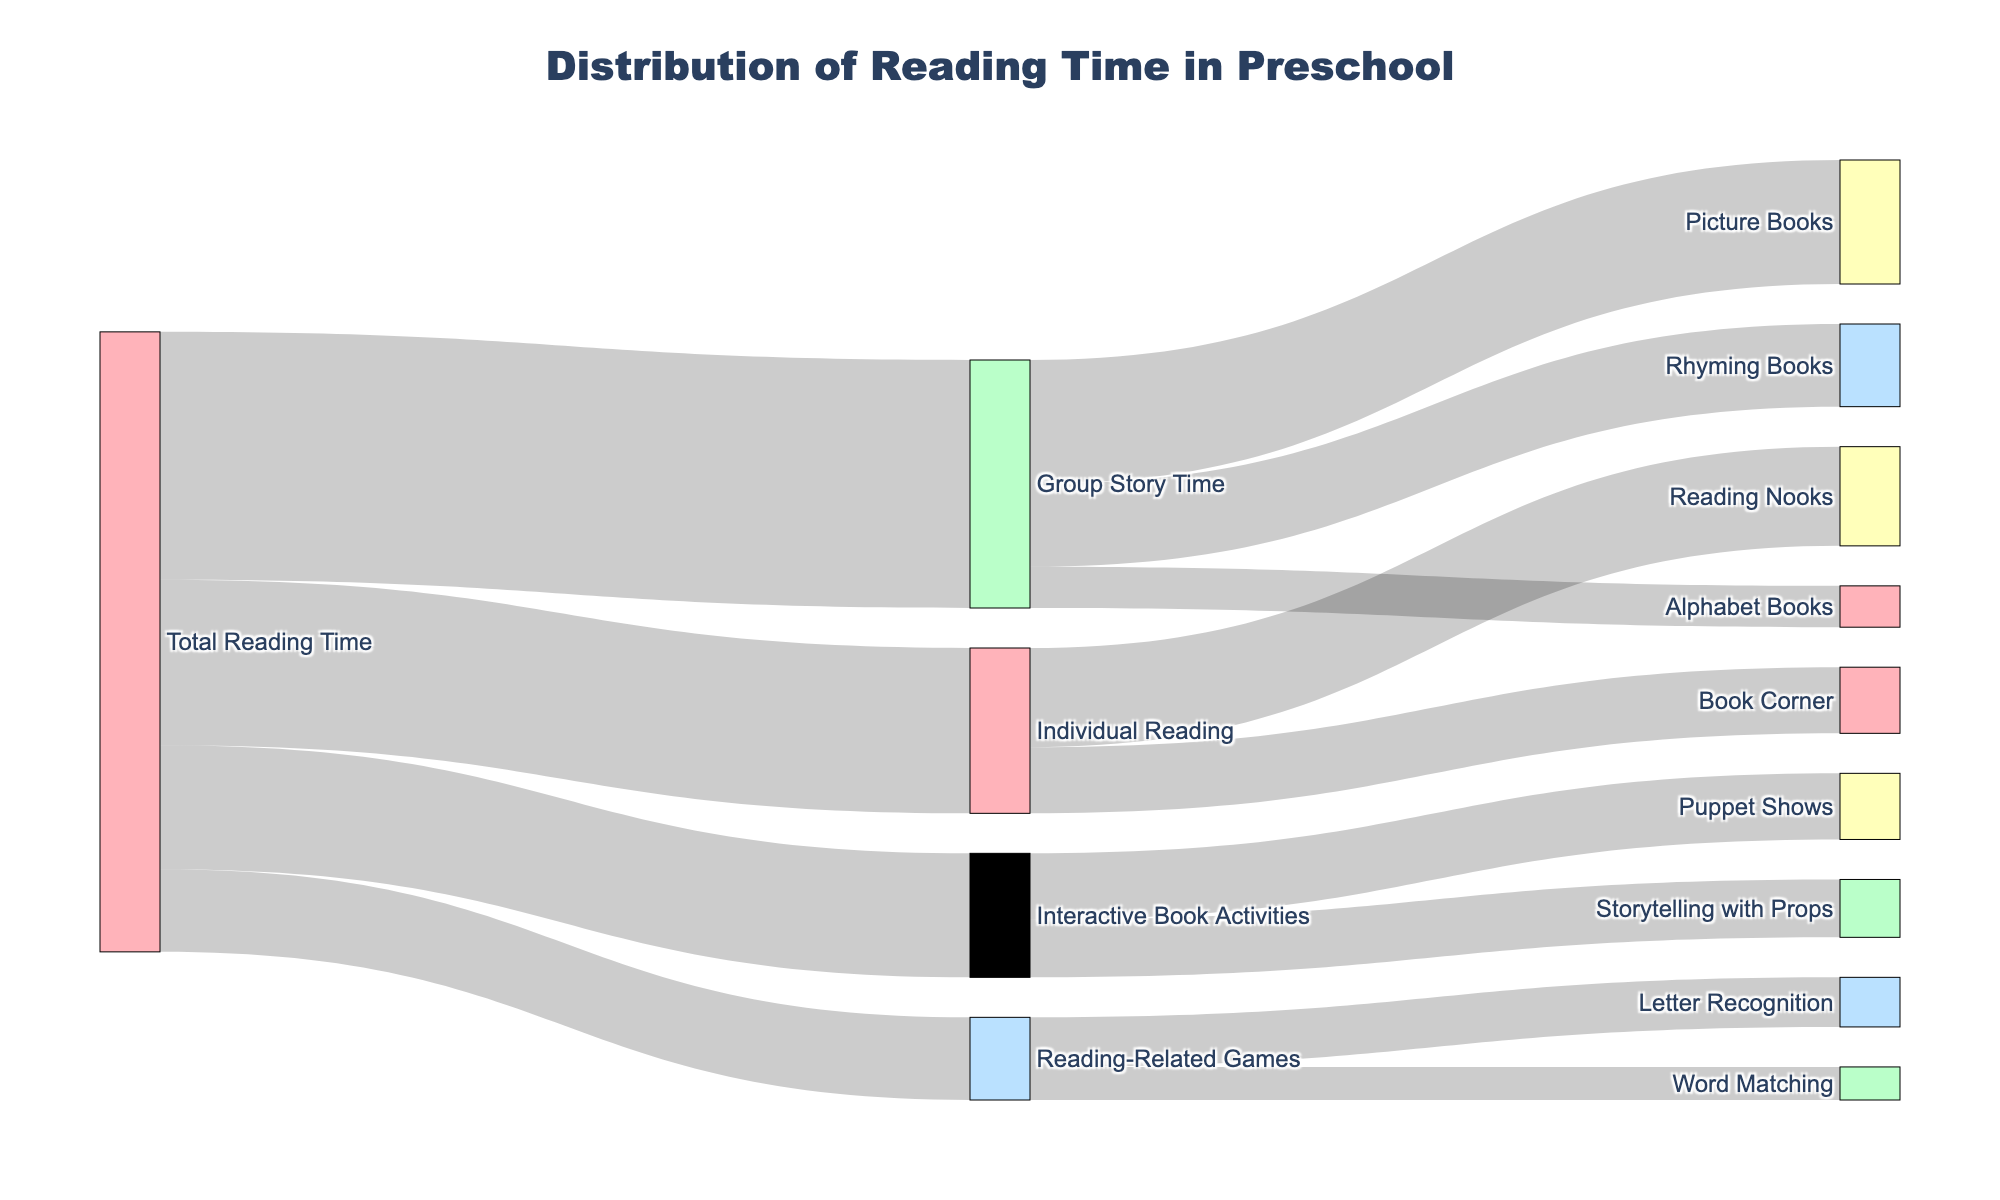what is the total reading time dedicated to Group Story Time? We observe the flow from "Total Reading Time" to "Group Story Time." The label on the connection indicates 30.
Answer: 30 how much time is spent on Puppet Shows during Interactive Book Activities? Look at the stream connecting "Interactive Book Activities" to "Puppet Shows" in the diagram. The label on this connection shows 8.
Answer: 8 which activity has the highest reading time allocation from Group Story Time? Reviewing all streams originating from "Group Story Time" and comparing their values, "Picture Books" has the highest time with 15.
Answer: Picture Books how does the reading time for Storytelling with Props compare to Word Matching? Examine the flow labels for "Storytelling with Props" (7) and "Word Matching" (4). Since 7 is greater than 4, Storytelling with Props has more time.
Answer: Storytelling with Props has more time what portion of the total reading time is spent on Alphabet Books during Group Story Time? Summing the streams from "Total Reading Time" to "Group Story Time" (30) and then checking "Group Story Time" to "Alphabet Books" (5), we compute (5/30) * 100 to get the percentage.
Answer: Approximately 16.67% if time for Group Story Time and Interactive Book Activities is added together, how much does that total time? Adding the time from "Total Reading Time" to "Group Story Time" (30) to "Interactive Book Activities" (15), we get 30 + 15.
Answer: 45 which activity receives the least individual reading time: Reading Nooks or Book Corner? Compare the flows: "Reading Nooks" (12) and "Book Corner" (8). Since 8 is less than 12, "Book Corner" receives less time.
Answer: Book Corner what is the combined reading time allocated to Letter Recognition and Word Matching in Reading-Related Games? Adding the stream values from "Reading-Related Games" to "Letter Recognition" (6) and "Word Matching" (4), we calculate 6 + 4.
Answer: 10 how much time is allotted to Interactive Book Activities compared to Reading-Related Games? The flow for "Interactive Book Activities" is labeled 15, and for "Reading-Related Games," it is labeled 10. 15 is greater than 10, so more time is given to Interactive Book Activities.
Answer: Interactive Book Activities has more time how many different activities are part of Total Reading Time according to the diagram? Count the unique connections originating from "Total Reading Time": "Group Story Time," "Individual Reading," "Interactive Book Activities," and "Reading-Related Games." There are four activities.
Answer: 4 